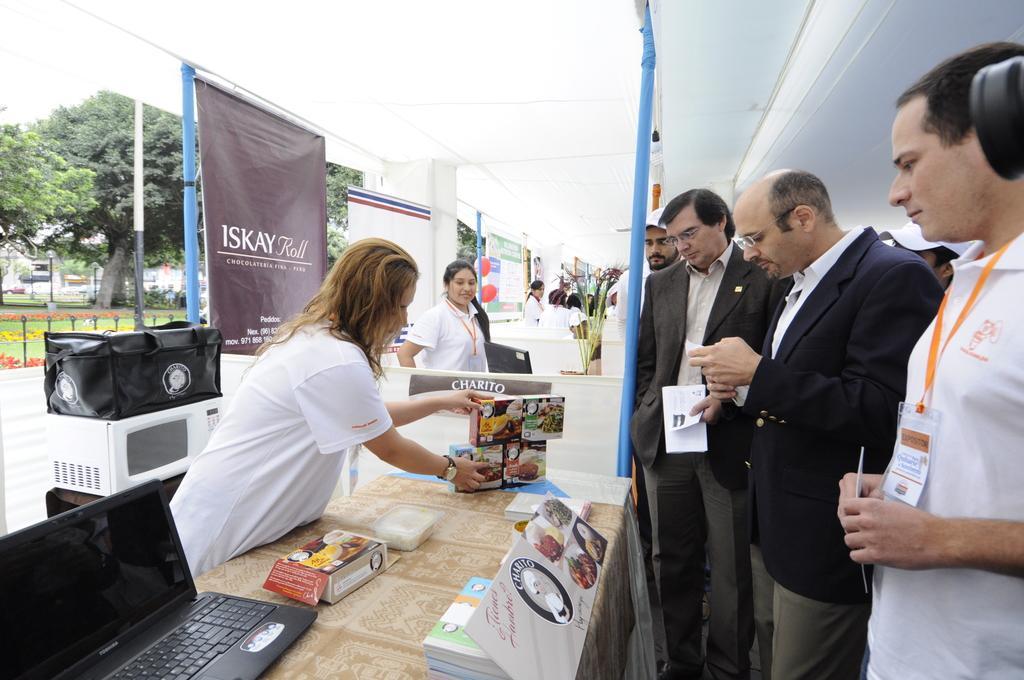How would you summarize this image in a sentence or two? In this image, we can see a group of people. Few people are holding some objects. Here we can see a table. Few things, laptop and object are placed on it. Background we can see bag, microwave oven, banners, rods, trees, poles, flowers, grass and few objects. Top of the image, we can see white color. 